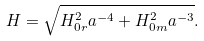Convert formula to latex. <formula><loc_0><loc_0><loc_500><loc_500>H = \sqrt { H _ { 0 r } ^ { 2 } a ^ { - 4 } + H _ { 0 m } ^ { 2 } a ^ { - 3 } } .</formula> 